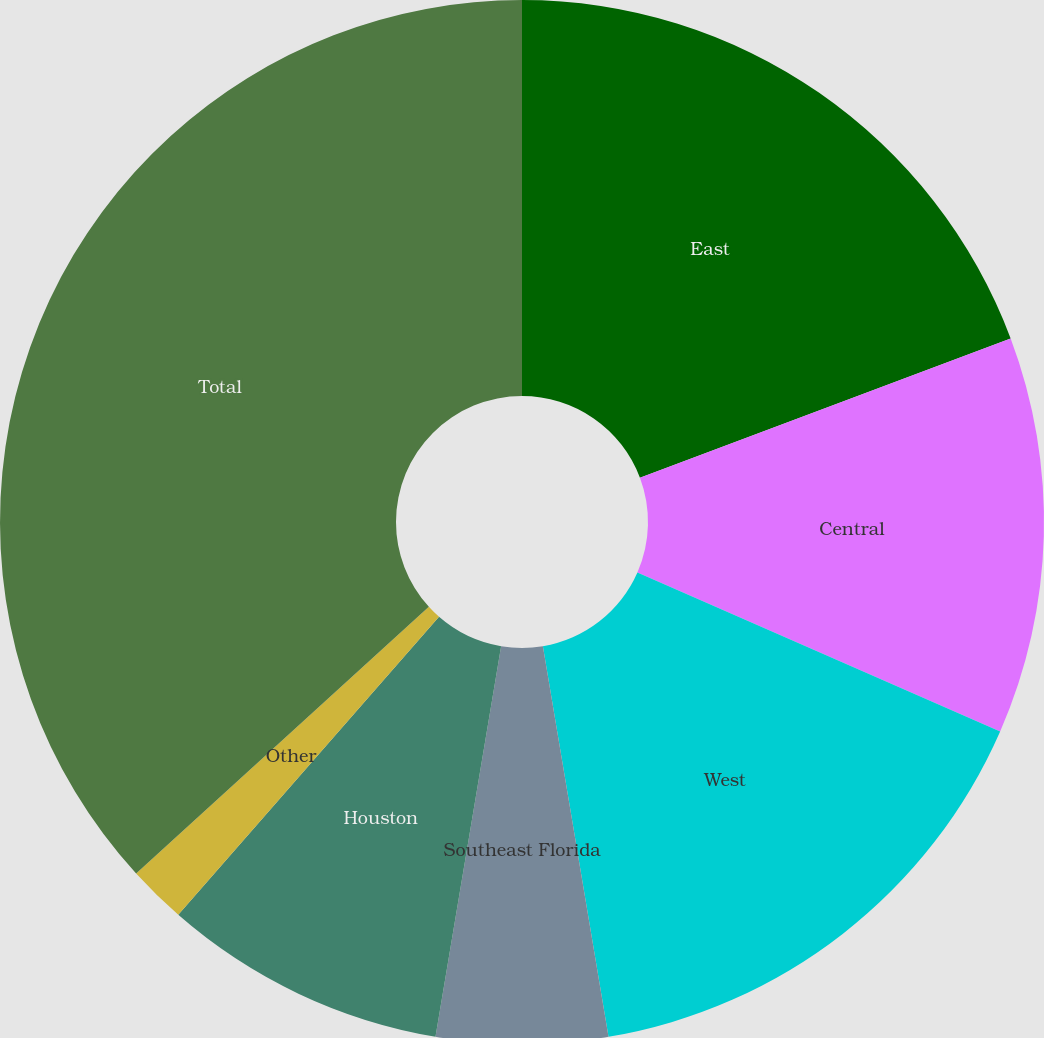Convert chart to OTSL. <chart><loc_0><loc_0><loc_500><loc_500><pie_chart><fcel>East<fcel>Central<fcel>West<fcel>Southeast Florida<fcel>Houston<fcel>Other<fcel>Total<nl><fcel>19.28%<fcel>12.29%<fcel>15.78%<fcel>5.3%<fcel>8.79%<fcel>1.8%<fcel>36.76%<nl></chart> 